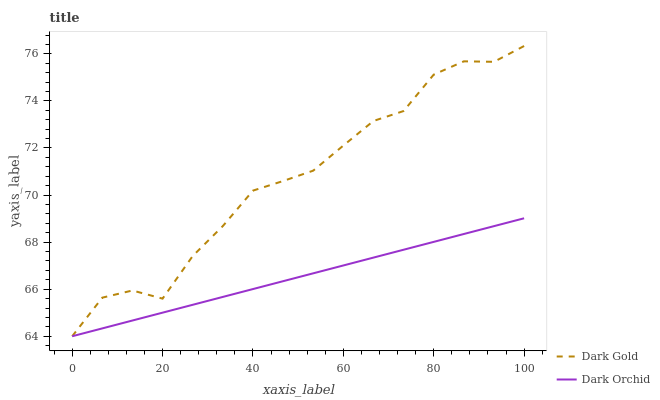Does Dark Orchid have the minimum area under the curve?
Answer yes or no. Yes. Does Dark Gold have the maximum area under the curve?
Answer yes or no. Yes. Does Dark Gold have the minimum area under the curve?
Answer yes or no. No. Is Dark Orchid the smoothest?
Answer yes or no. Yes. Is Dark Gold the roughest?
Answer yes or no. Yes. Is Dark Gold the smoothest?
Answer yes or no. No. Does Dark Orchid have the lowest value?
Answer yes or no. Yes. Does Dark Gold have the highest value?
Answer yes or no. Yes. Does Dark Orchid intersect Dark Gold?
Answer yes or no. Yes. Is Dark Orchid less than Dark Gold?
Answer yes or no. No. Is Dark Orchid greater than Dark Gold?
Answer yes or no. No. 